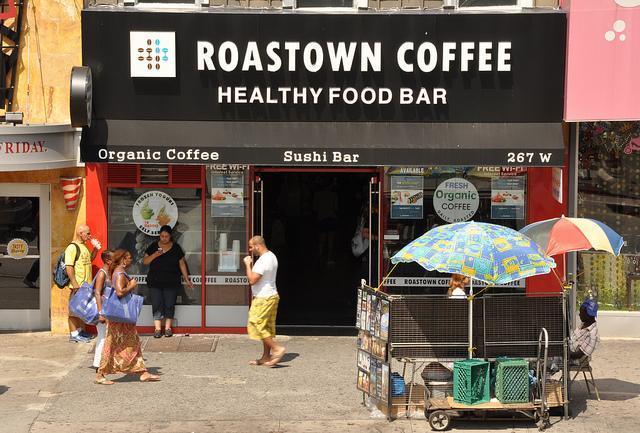How many people are seated in this picture?
Give a very brief answer. 1. How many umbrellas are in the photo?
Give a very brief answer. 2. How many people are there?
Give a very brief answer. 3. 